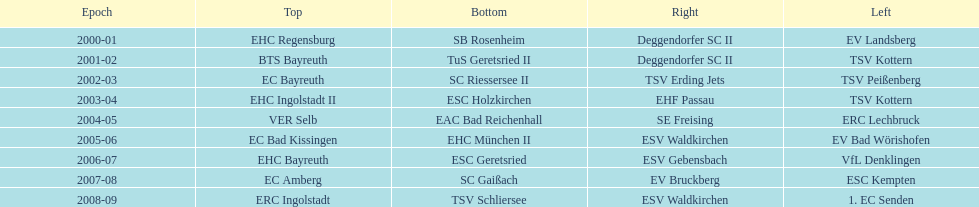Could you parse the entire table as a dict? {'header': ['Epoch', 'Top', 'Bottom', 'Right', 'Left'], 'rows': [['2000-01', 'EHC Regensburg', 'SB Rosenheim', 'Deggendorfer SC II', 'EV Landsberg'], ['2001-02', 'BTS Bayreuth', 'TuS Geretsried II', 'Deggendorfer SC II', 'TSV Kottern'], ['2002-03', 'EC Bayreuth', 'SC Riessersee II', 'TSV Erding Jets', 'TSV Peißenberg'], ['2003-04', 'EHC Ingolstadt II', 'ESC Holzkirchen', 'EHF Passau', 'TSV Kottern'], ['2004-05', 'VER Selb', 'EAC Bad Reichenhall', 'SE Freising', 'ERC Lechbruck'], ['2005-06', 'EC Bad Kissingen', 'EHC München II', 'ESV Waldkirchen', 'EV Bad Wörishofen'], ['2006-07', 'EHC Bayreuth', 'ESC Geretsried', 'ESV Gebensbach', 'VfL Denklingen'], ['2007-08', 'EC Amberg', 'SC Gaißach', 'EV Bruckberg', 'ESC Kempten'], ['2008-09', 'ERC Ingolstadt', 'TSV Schliersee', 'ESV Waldkirchen', '1. EC Senden']]} What is the number of times deggendorfer sc ii is on the list? 2. 